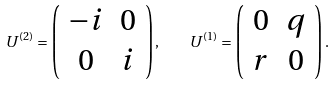Convert formula to latex. <formula><loc_0><loc_0><loc_500><loc_500>U ^ { ( 2 ) } = \left ( \begin{array} { c c } - i & 0 \\ 0 & i \end{array} \right ) , \quad U ^ { ( 1 ) } = \left ( \begin{array} { c c } 0 & q \\ r & 0 \end{array} \right ) .</formula> 